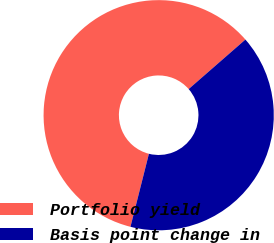<chart> <loc_0><loc_0><loc_500><loc_500><pie_chart><fcel>Portfolio yield<fcel>Basis point change in<nl><fcel>59.64%<fcel>40.36%<nl></chart> 